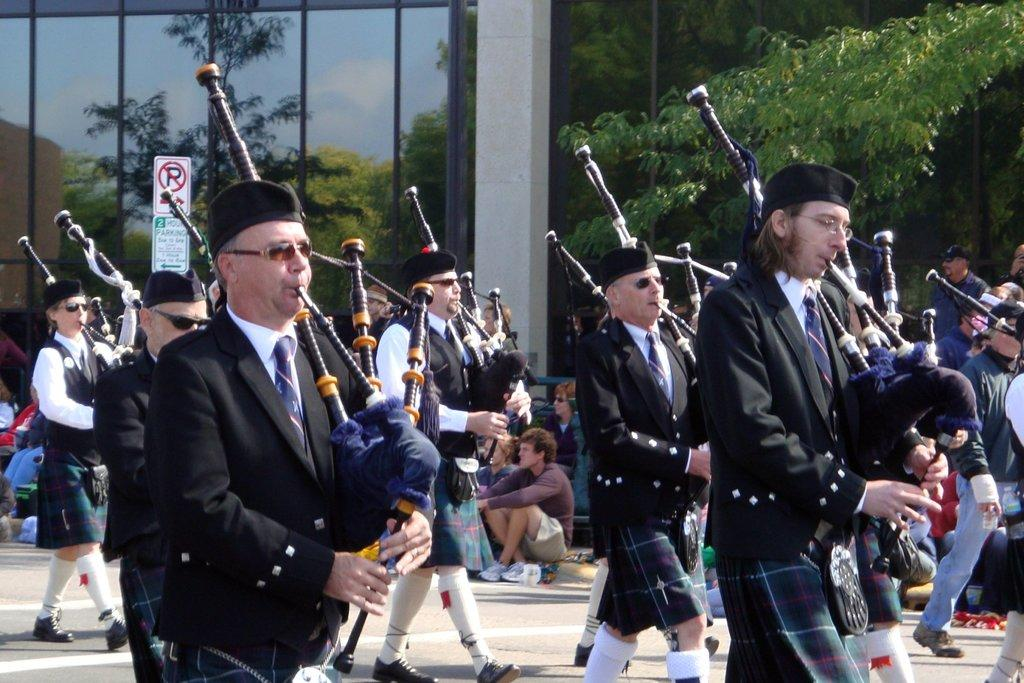What is happening in the foreground of the image? There are people in the foreground of the image, and they are holding musical instruments. What can be seen in the background of the image? There are trees, at least one building, and a pole in the background of the image. What type of sock is the person in the image wearing on their back? There is no person wearing a sock on their back in the image, as the image features people holding musical instruments and the focus is not on their clothing or body position. 